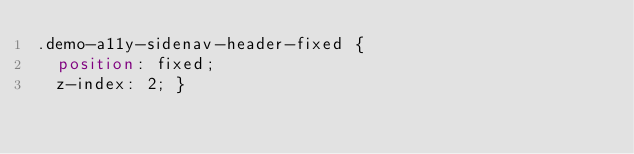Convert code to text. <code><loc_0><loc_0><loc_500><loc_500><_CSS_>.demo-a11y-sidenav-header-fixed {
  position: fixed;
  z-index: 2; }
</code> 